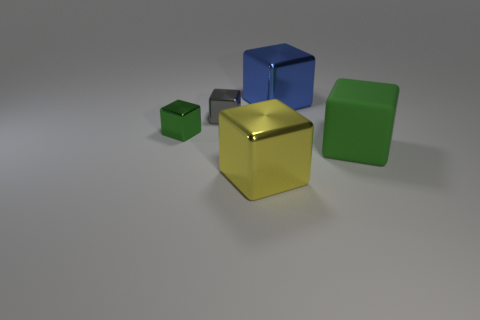How many other things are there of the same color as the matte thing?
Your answer should be very brief. 1. The blue thing is what size?
Offer a terse response. Large. There is a green thing that is right of the small green object to the left of the large blue shiny thing; what is its size?
Offer a very short reply. Large. How many blocks have the same color as the matte thing?
Provide a succinct answer. 1. What number of green shiny things are there?
Your answer should be very brief. 1. What number of blue objects have the same material as the gray cube?
Give a very brief answer. 1. There is a yellow metallic object that is the same shape as the green rubber object; what is its size?
Ensure brevity in your answer.  Large. What is the gray thing made of?
Provide a short and direct response. Metal. What material is the tiny block that is in front of the tiny metallic object that is right of the green object that is behind the big rubber block?
Keep it short and to the point. Metal. Are there any other things that have the same shape as the green matte thing?
Make the answer very short. Yes. 